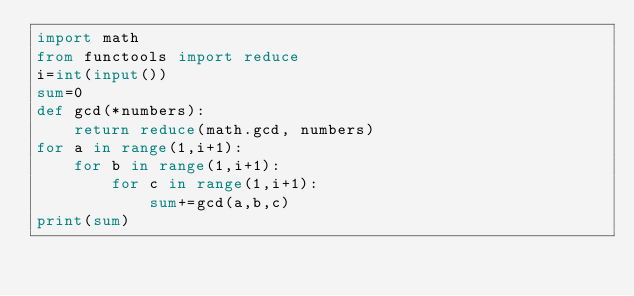<code> <loc_0><loc_0><loc_500><loc_500><_Python_>import math
from functools import reduce
i=int(input())
sum=0
def gcd(*numbers):
    return reduce(math.gcd, numbers)
for a in range(1,i+1):
    for b in range(1,i+1):
        for c in range(1,i+1):
            sum+=gcd(a,b,c)
print(sum)</code> 